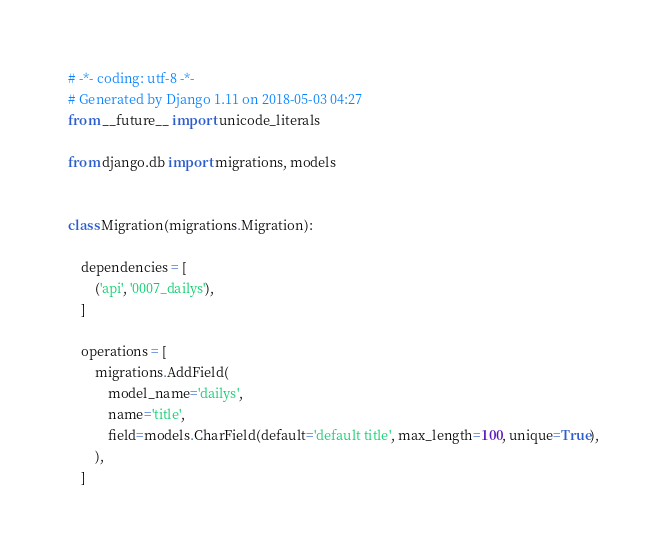Convert code to text. <code><loc_0><loc_0><loc_500><loc_500><_Python_># -*- coding: utf-8 -*-
# Generated by Django 1.11 on 2018-05-03 04:27
from __future__ import unicode_literals

from django.db import migrations, models


class Migration(migrations.Migration):

    dependencies = [
        ('api', '0007_dailys'),
    ]

    operations = [
        migrations.AddField(
            model_name='dailys',
            name='title',
            field=models.CharField(default='default title', max_length=100, unique=True),
        ),
    ]
</code> 